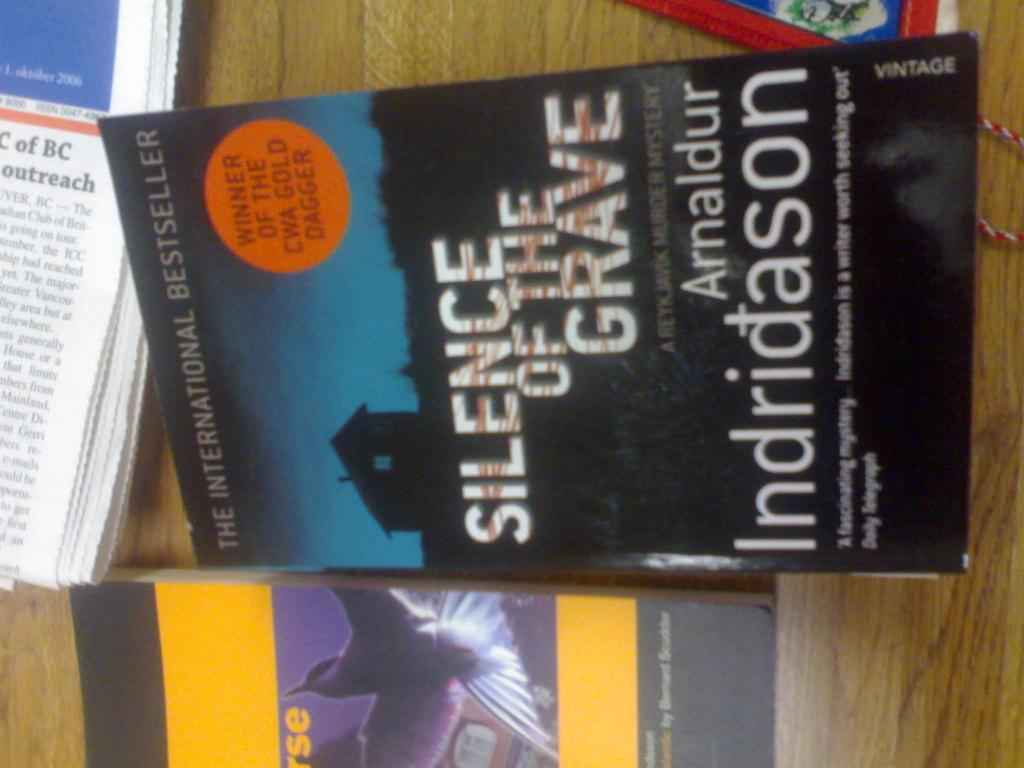<image>
Provide a brief description of the given image. a book that is titled 'silence of the grave' by arnaldur indridason 